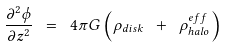Convert formula to latex. <formula><loc_0><loc_0><loc_500><loc_500>\frac { \partial ^ { 2 } \phi } { \partial z ^ { 2 } } \ = \ 4 \pi G \left ( \rho _ { d i s k } \ + \ \rho ^ { e f f } _ { h a l o } \right )</formula> 